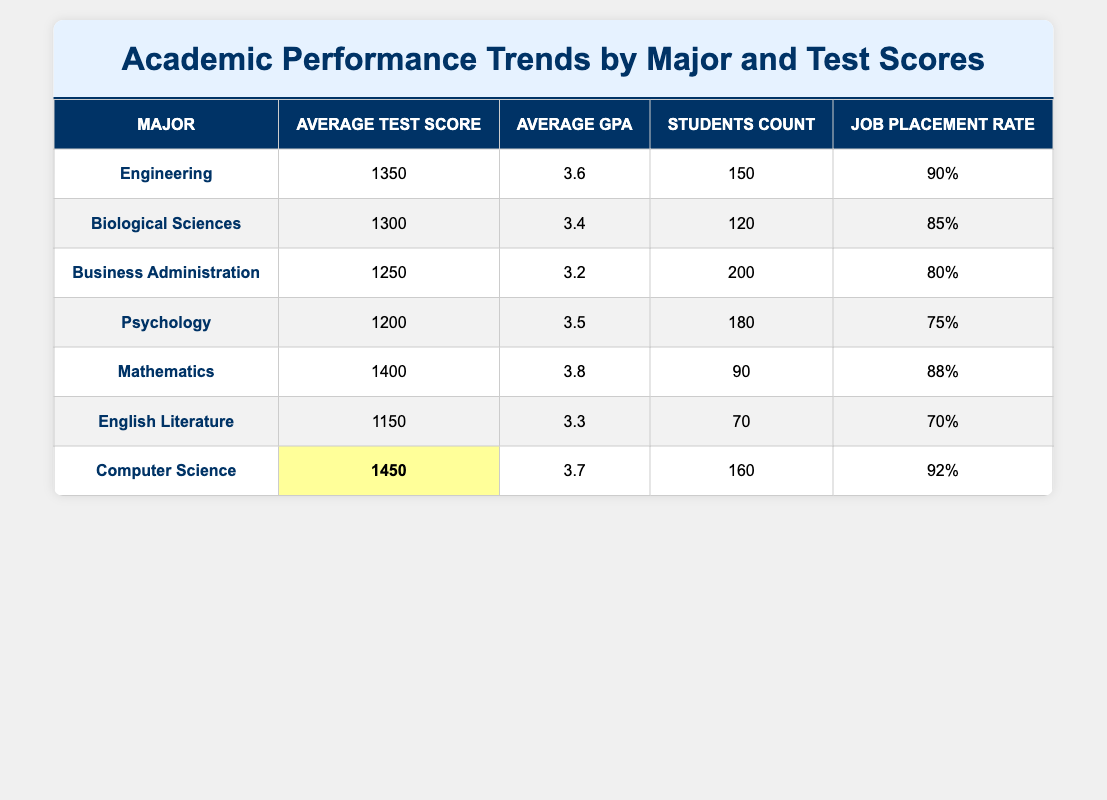What is the average test score for students majoring in Engineering? The table shows that the average test score for Engineering majors is listed as 1350. Therefore, the answer is directly obtained from the relevant row in the table.
Answer: 1350 What is the job placement rate for students majoring in Mathematics? By looking at the table under the Mathematics row, we can see that the job placement rate is 88%. This information is a straightforward retrieval from the table.
Answer: 88% Which major has the highest average test score? The highest average test score can be found by comparing the average test scores of each major listed in the table. The Computer Science major has the highest average test score of 1450.
Answer: Computer Science What is the difference between the average test scores of Computer Science and Business Administration? The average test score for Computer Science is 1450, while for Business Administration, it is 1250. The difference is calculated as 1450 - 1250 = 200. Thus, the average test score difference is 200.
Answer: 200 Is the average GPA for students in Biological Sciences greater than 3.4? According to the table for Biological Sciences, the average GPA is 3.4. Since the question is asking if it is greater than this value, the response is no.
Answer: No What is the total number of students across all majors listed? To find the total number of students, we sum the students count from each major: 150 (Engineering) + 120 (Biological Sciences) + 200 (Business Administration) + 180 (Psychology) + 90 (Mathematics) + 70 (English Literature) + 160 (Computer Science) = 1070. This involves both addition of each row's students count.
Answer: 1070 Which major has a job placement rate above 85%? From the table, the majors with job placement rates above 85% are Engineering (90%) and Computer Science (92%). We check the job placement rates for each major and find that these two meet the criteria.
Answer: Engineering, Computer Science What is the average GPA for students majoring in Psychology? The table provides that the average GPA for Psychology is 3.5. This is a straightforward retrieval from the relevant row.
Answer: 3.5 How many majors have an average test score between 1200 and 1300? Examining the average test scores, we find Psychology (1200) and Biological Sciences (1300) fall within this range. Thus, we check the number of majors meeting this condition and confirm there are 2 majors.
Answer: 2 